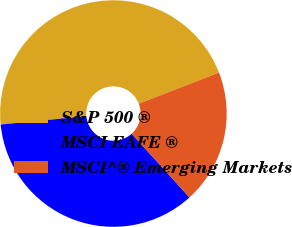Convert chart. <chart><loc_0><loc_0><loc_500><loc_500><pie_chart><fcel>S&P 500 ®<fcel>MSCI EAFE ®<fcel>MSCI^® Emerging Markets<nl><fcel>45.66%<fcel>35.17%<fcel>19.17%<nl></chart> 